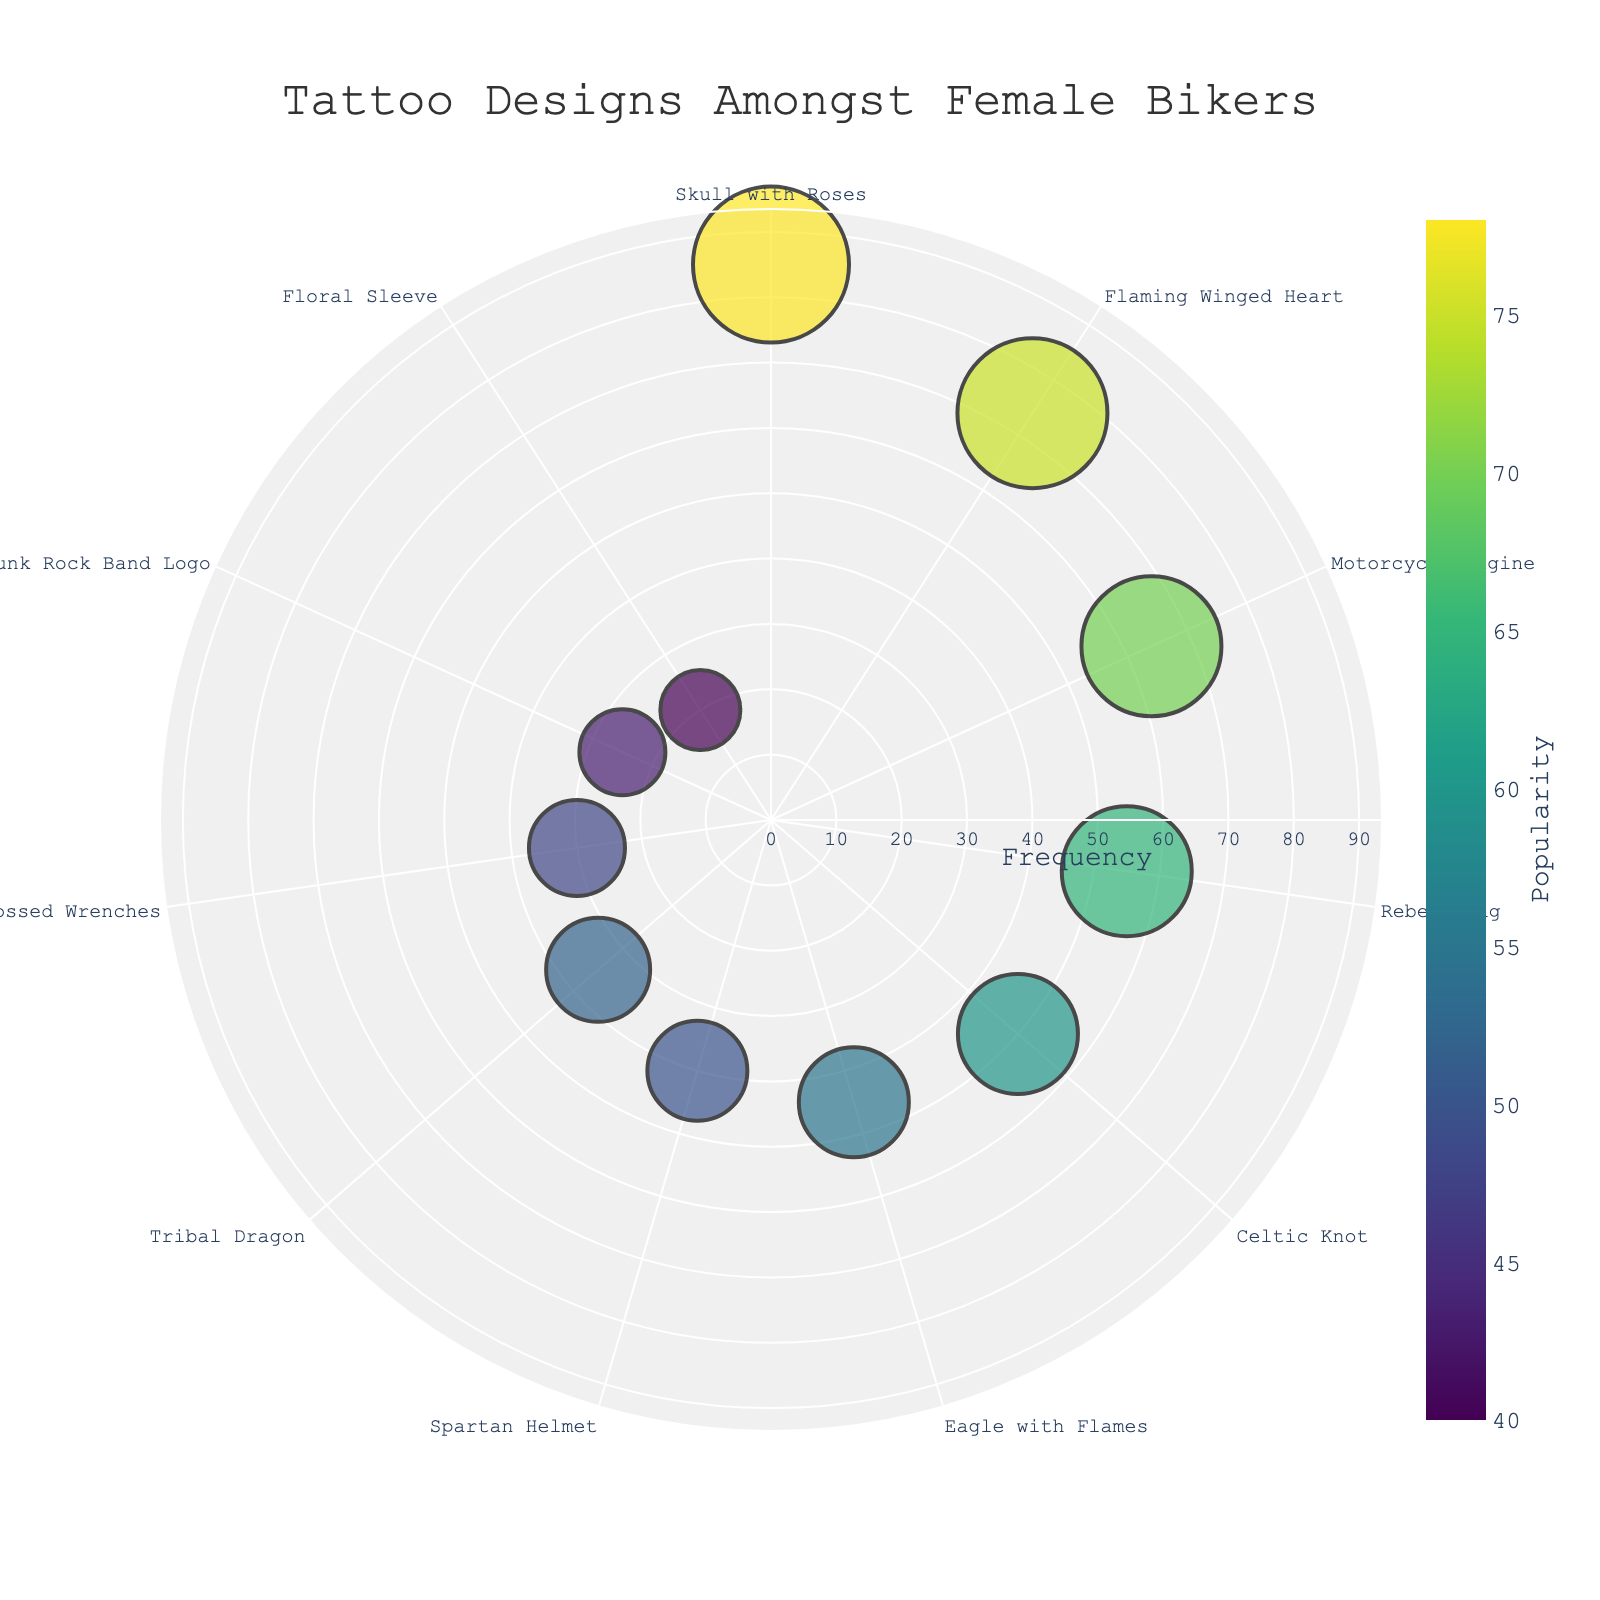What's the title of the figure? Look at the top of the chart where the title is usually placed.
Answer: Tattoo Designs Amongst Female Bikers How many tattoo designs are displayed on the chart? Count the number of distinct marker points on the chart.
Answer: 11 Which tattoo design has the highest frequency? Look for the marker with the largest radial distance from the center. The accompanying label tells us the design.
Answer: Skull with Roses What's the frequency and popularity of the "Eagle with Flames" tattoo design? Locate the "Eagle with Flames" design on the chart and check its position and size. The radial distance from the center represents frequency, while the size and color represent popularity.
Answer: Frequency: 45, Popularity: 55 Which tattoo design is the least popular? Look for the smallest and possibly least colorful marker. Read its label to identify the design.
Answer: Floral Sleeve What is the difference in frequency between the "Skull with Roses" and "Floral Sleeve" designs? Find the frequency values for both designs and subtract the smaller from the larger.
Answer: 65 Which is more popular, the "Motorcycle Engine" or the "Rebel Flag" tattoo design? Find the two designs and compare their marker sizes and colors.
Answer: Motorcycle Engine What are the three most frequent tattoo designs? Identify the three markers furthest from the center based on their radial distance. Read the labels of these markers.
Answer: Skull with Roses, Flaming Winged Heart, Motorcycle Engine Which tattoo design has a popularity of around 50? Look for a marker whose size and color indicate a popularity near 50. Check its label for the name.
Answer: Spartan Helmet Considering only the "Tribal Dragon" and "Punk Rock Band Logo" designs, which has a higher frequency and by how much? Find the frequency values for both designs and subtract the smaller from the larger.
Answer: Tribal Dragon, by 10 